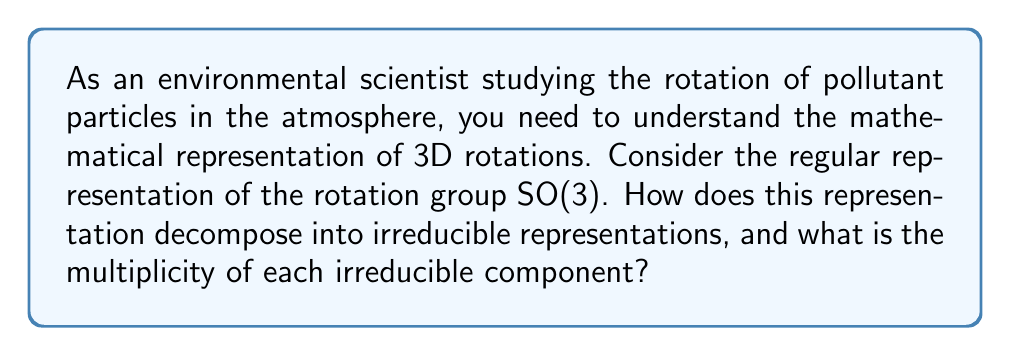What is the answer to this math problem? Let's approach this step-by-step:

1) The regular representation of SO(3) acts on the space of square-integrable functions on SO(3), denoted as $L^2(SO(3))$.

2) We can decompose this representation using the Peter-Weyl theorem, which states that for a compact Lie group G:

   $$L^2(G) \cong \bigoplus_{\rho \in \hat{G}} V_\rho \otimes V_\rho^*$$

   where $\hat{G}$ is the set of equivalence classes of irreducible representations of G, and $V_\rho$ is the vector space of the representation $\rho$.

3) For SO(3), the irreducible representations are indexed by non-negative integers $l = 0, 1, 2, ...$, corresponding to angular momentum in physics.

4) The dimension of the $l$-th irreducible representation is $2l+1$.

5) Therefore, the decomposition of the regular representation of SO(3) is:

   $$L^2(SO(3)) \cong \bigoplus_{l=0}^{\infty} V_l \otimes V_l^*$$

6) The dimension of $V_l \otimes V_l^*$ is $(2l+1)^2$, which is also the multiplicity of the $l$-th irreducible representation in the decomposition.

7) This means that each irreducible representation $V_l$ appears in the decomposition with multiplicity $2l+1$.
Answer: $\bigoplus_{l=0}^{\infty} (2l+1)V_l$ 